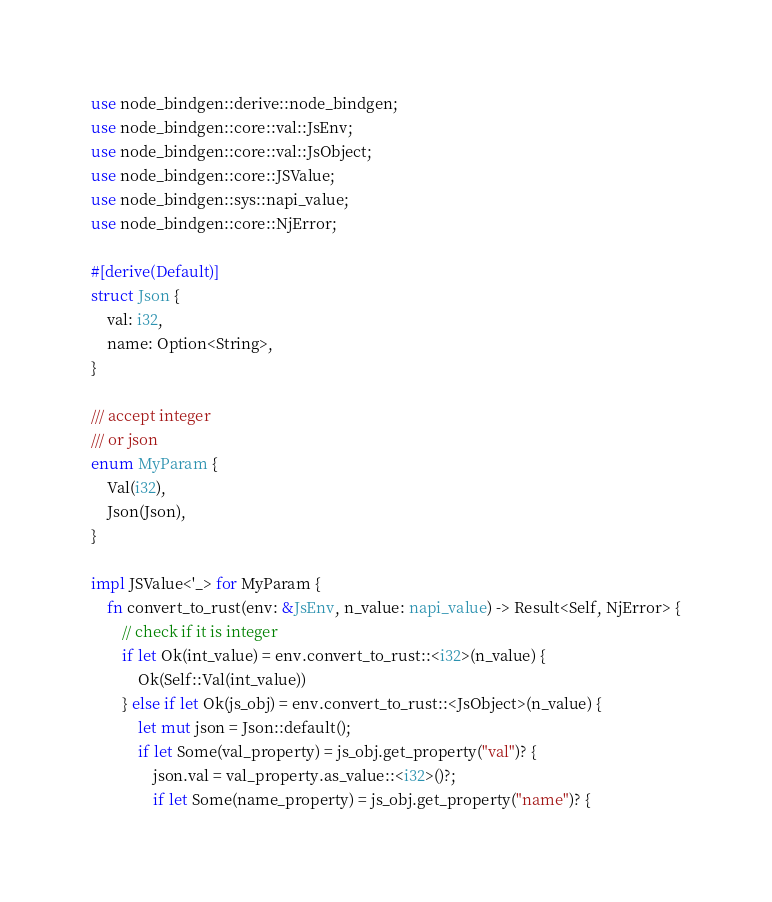Convert code to text. <code><loc_0><loc_0><loc_500><loc_500><_Rust_>use node_bindgen::derive::node_bindgen;
use node_bindgen::core::val::JsEnv;
use node_bindgen::core::val::JsObject;
use node_bindgen::core::JSValue;
use node_bindgen::sys::napi_value;
use node_bindgen::core::NjError;

#[derive(Default)]
struct Json {
    val: i32,
    name: Option<String>,
}

/// accept integer
/// or json
enum MyParam {
    Val(i32),
    Json(Json),
}

impl JSValue<'_> for MyParam {
    fn convert_to_rust(env: &JsEnv, n_value: napi_value) -> Result<Self, NjError> {
        // check if it is integer
        if let Ok(int_value) = env.convert_to_rust::<i32>(n_value) {
            Ok(Self::Val(int_value))
        } else if let Ok(js_obj) = env.convert_to_rust::<JsObject>(n_value) {
            let mut json = Json::default();
            if let Some(val_property) = js_obj.get_property("val")? {
                json.val = val_property.as_value::<i32>()?;
                if let Some(name_property) = js_obj.get_property("name")? {</code> 